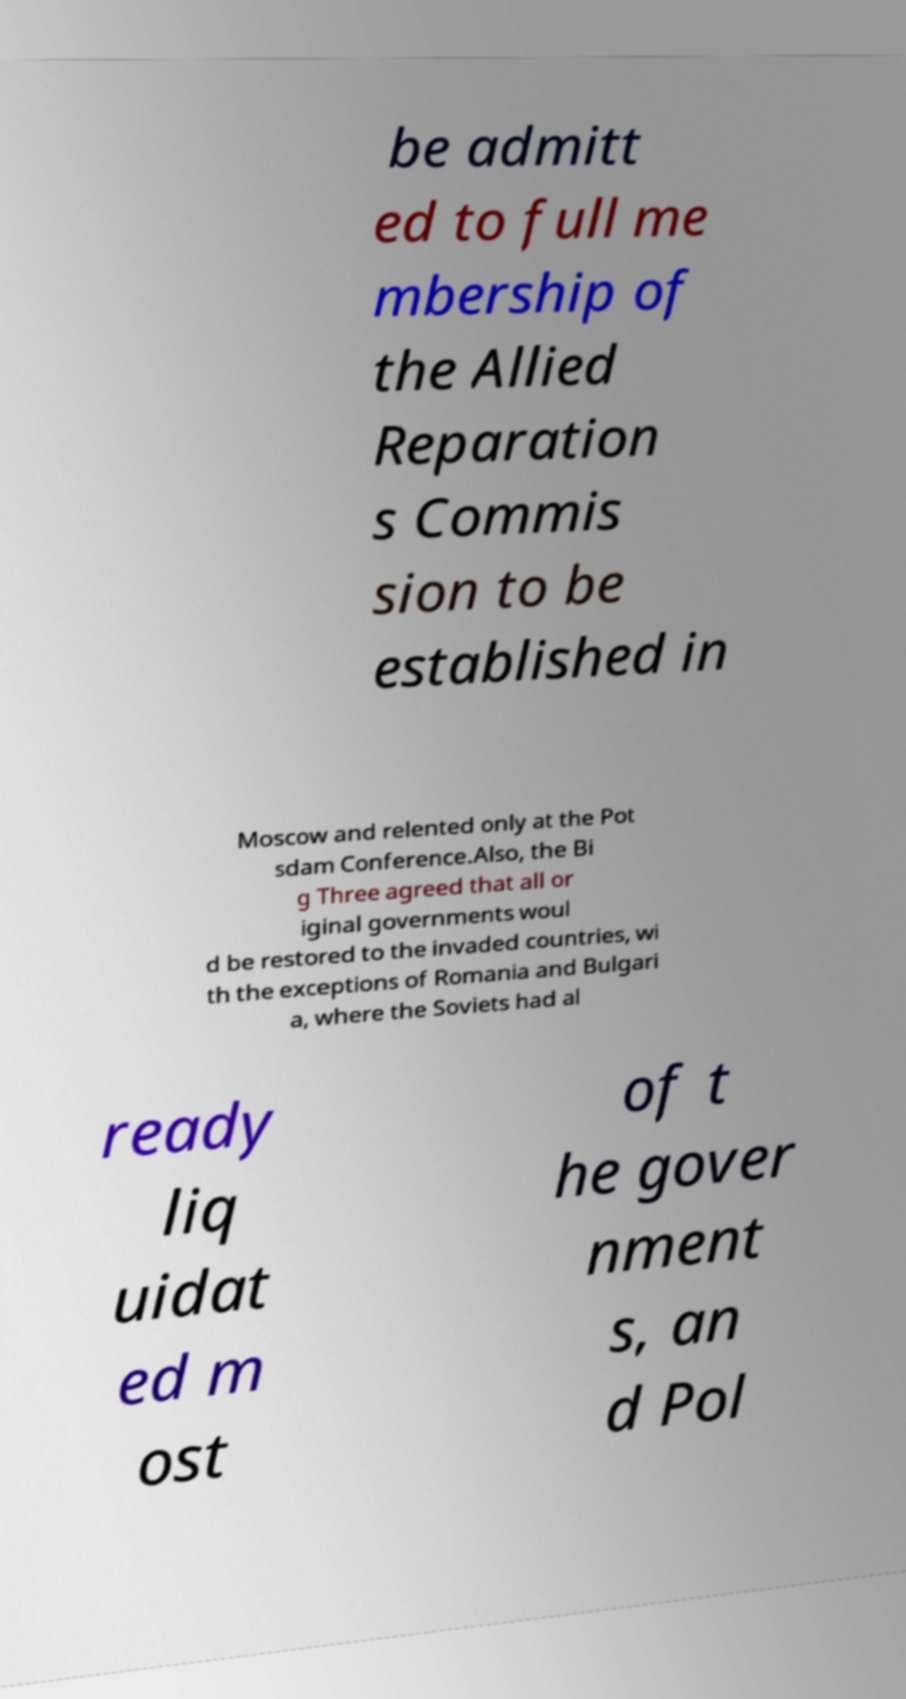Can you accurately transcribe the text from the provided image for me? be admitt ed to full me mbership of the Allied Reparation s Commis sion to be established in Moscow and relented only at the Pot sdam Conference.Also, the Bi g Three agreed that all or iginal governments woul d be restored to the invaded countries, wi th the exceptions of Romania and Bulgari a, where the Soviets had al ready liq uidat ed m ost of t he gover nment s, an d Pol 